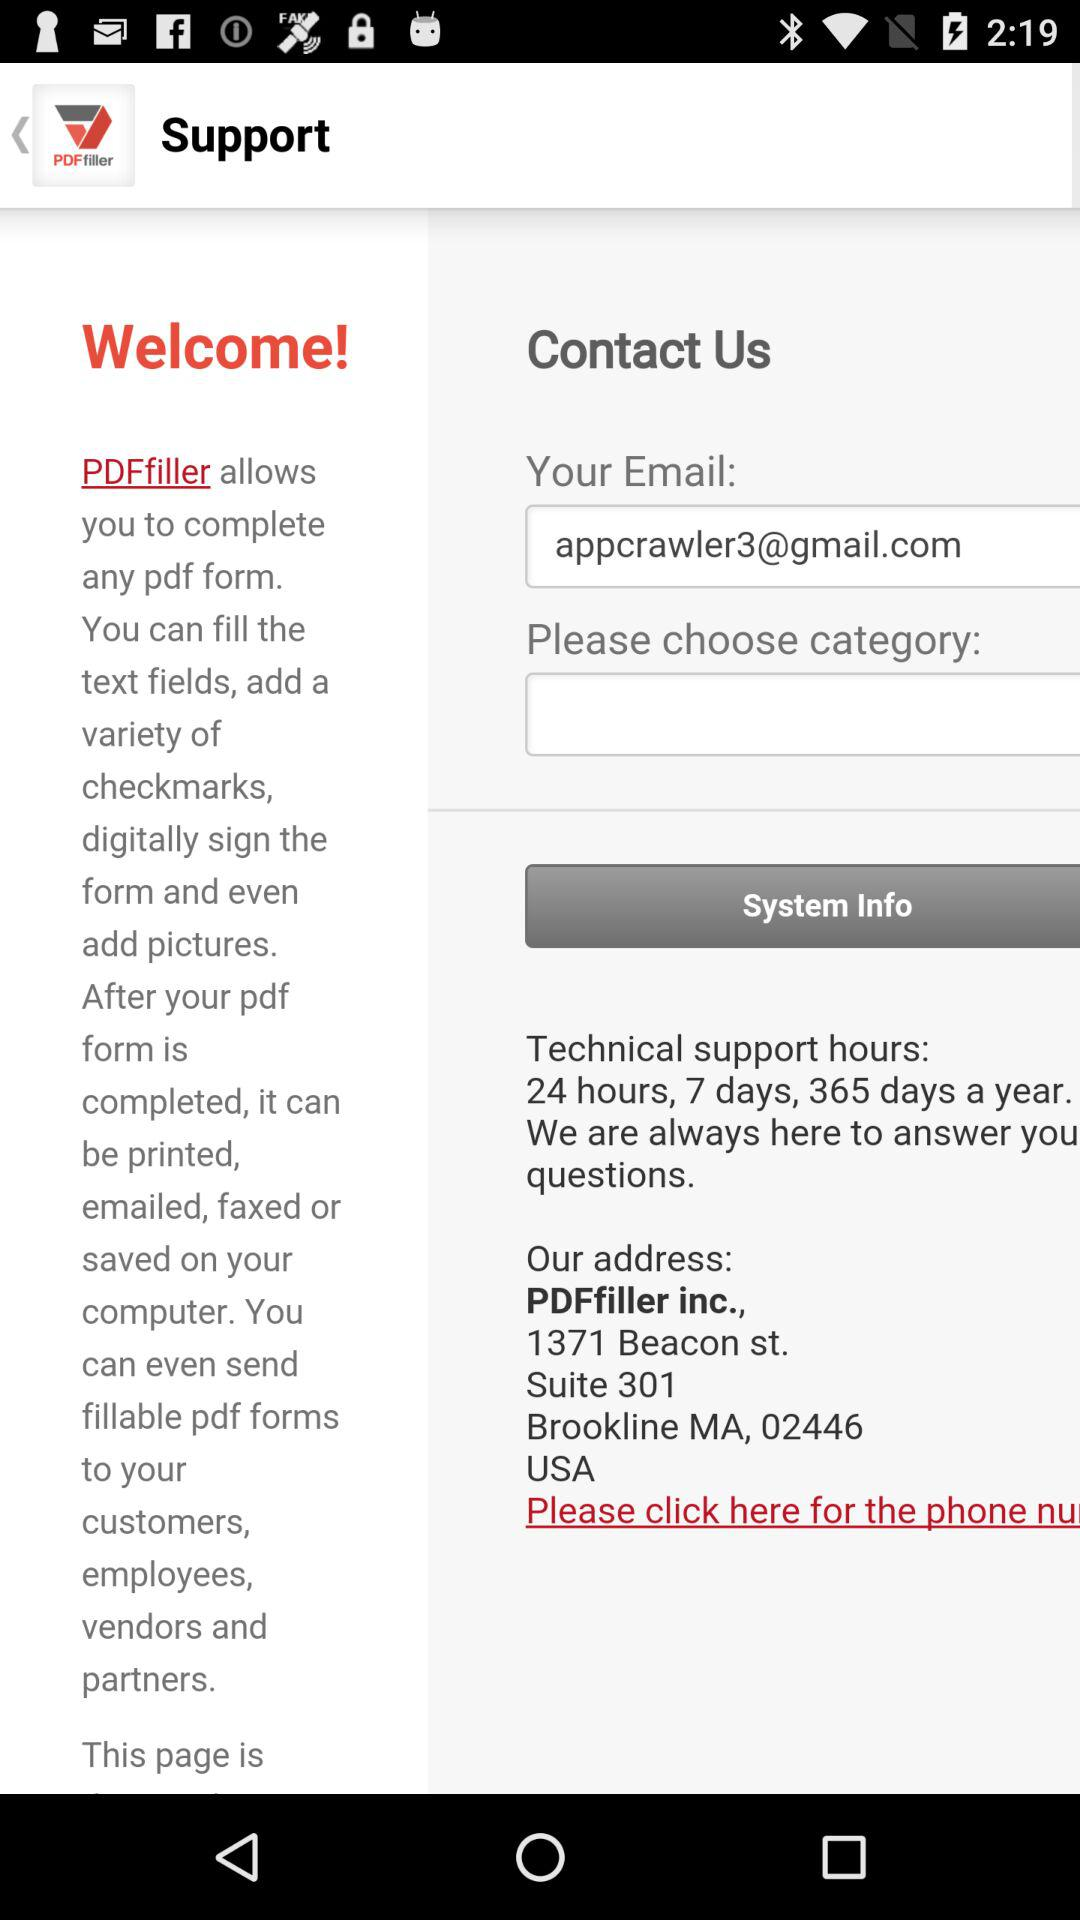Which category has been chosen?
When the provided information is insufficient, respond with <no answer>. <no answer> 